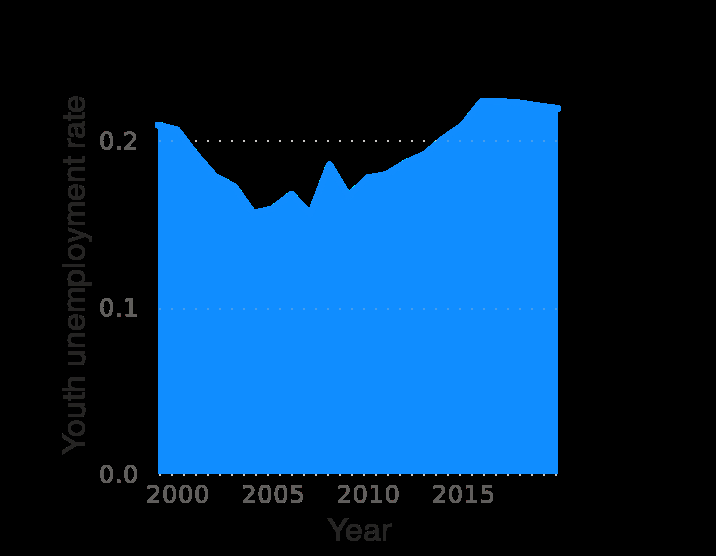<image>
What was the trend in youth employment rate in Morocco from 2003 to 2015? The youth employment rate in Morocco was the lowest in around 2003 until spiking around 2007, and then gradually increasing through to 2015. Was the youth employment rate in Morocco the highest in around 2003 until spiking around 2007, and then gradually decreasing through to 2015? No.The youth employment rate in Morocco was the lowest in around 2003 until spiking around 2007, and then gradually increasing through to 2015. 